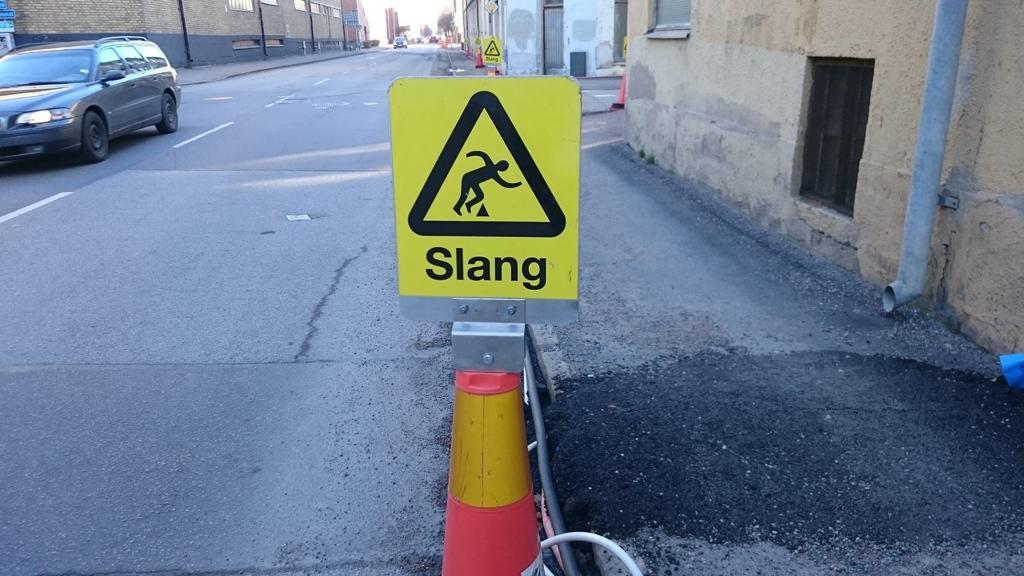In one or two sentences, can you explain what this image depicts? In front of the picture, we see a pole and a board in yellow color with some text written on it. At the bottom, we see the road. On the left side, we see the car moving on the road. On either side of the picture, we see the buildings. In the background, we see the trees, buildings and a car moving on the road. This picture is clicked outside the city. 